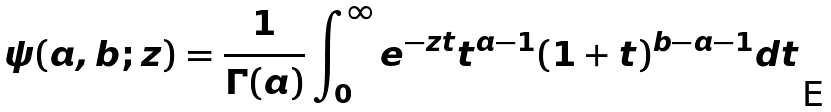Convert formula to latex. <formula><loc_0><loc_0><loc_500><loc_500>\psi ( a , b ; z ) = \frac { 1 } { \Gamma ( a ) } \int _ { 0 } ^ { \infty } e ^ { - z t } t ^ { a - 1 } ( 1 + t ) ^ { b - a - 1 } d t</formula> 